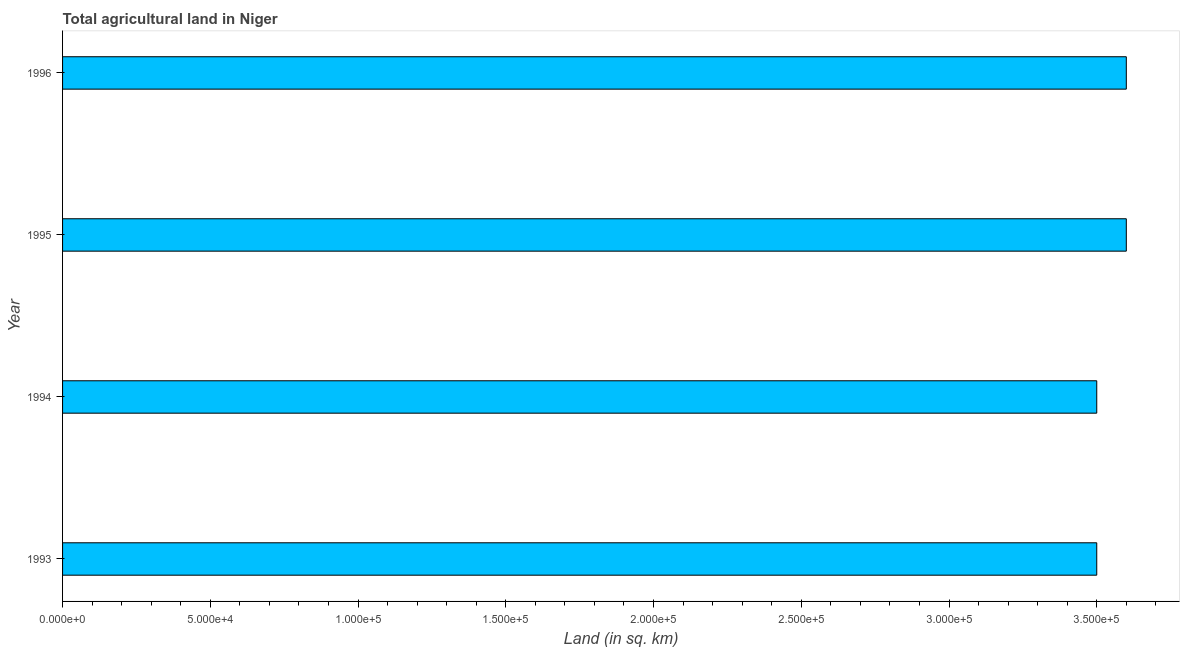What is the title of the graph?
Your response must be concise. Total agricultural land in Niger. What is the label or title of the X-axis?
Provide a short and direct response. Land (in sq. km). What is the agricultural land in 1996?
Your answer should be compact. 3.60e+05. What is the sum of the agricultural land?
Provide a short and direct response. 1.42e+06. What is the difference between the agricultural land in 1994 and 1995?
Offer a terse response. -10000. What is the average agricultural land per year?
Provide a short and direct response. 3.55e+05. What is the median agricultural land?
Offer a terse response. 3.55e+05. In how many years, is the agricultural land greater than 140000 sq. km?
Keep it short and to the point. 4. Do a majority of the years between 1993 and 1994 (inclusive) have agricultural land greater than 180000 sq. km?
Your answer should be very brief. Yes. Is the agricultural land in 1994 less than that in 1995?
Keep it short and to the point. Yes. Is the difference between the agricultural land in 1995 and 1996 greater than the difference between any two years?
Your response must be concise. No. What is the difference between the highest and the second highest agricultural land?
Provide a short and direct response. 0. In how many years, is the agricultural land greater than the average agricultural land taken over all years?
Your answer should be very brief. 2. How many bars are there?
Your response must be concise. 4. Are the values on the major ticks of X-axis written in scientific E-notation?
Give a very brief answer. Yes. What is the Land (in sq. km) of 1993?
Offer a terse response. 3.50e+05. What is the Land (in sq. km) in 1994?
Provide a short and direct response. 3.50e+05. What is the Land (in sq. km) in 1995?
Your answer should be very brief. 3.60e+05. What is the difference between the Land (in sq. km) in 1994 and 1995?
Offer a terse response. -10000. What is the difference between the Land (in sq. km) in 1995 and 1996?
Give a very brief answer. 0. What is the ratio of the Land (in sq. km) in 1993 to that in 1994?
Your answer should be compact. 1. What is the ratio of the Land (in sq. km) in 1993 to that in 1995?
Your answer should be very brief. 0.97. What is the ratio of the Land (in sq. km) in 1994 to that in 1996?
Make the answer very short. 0.97. 